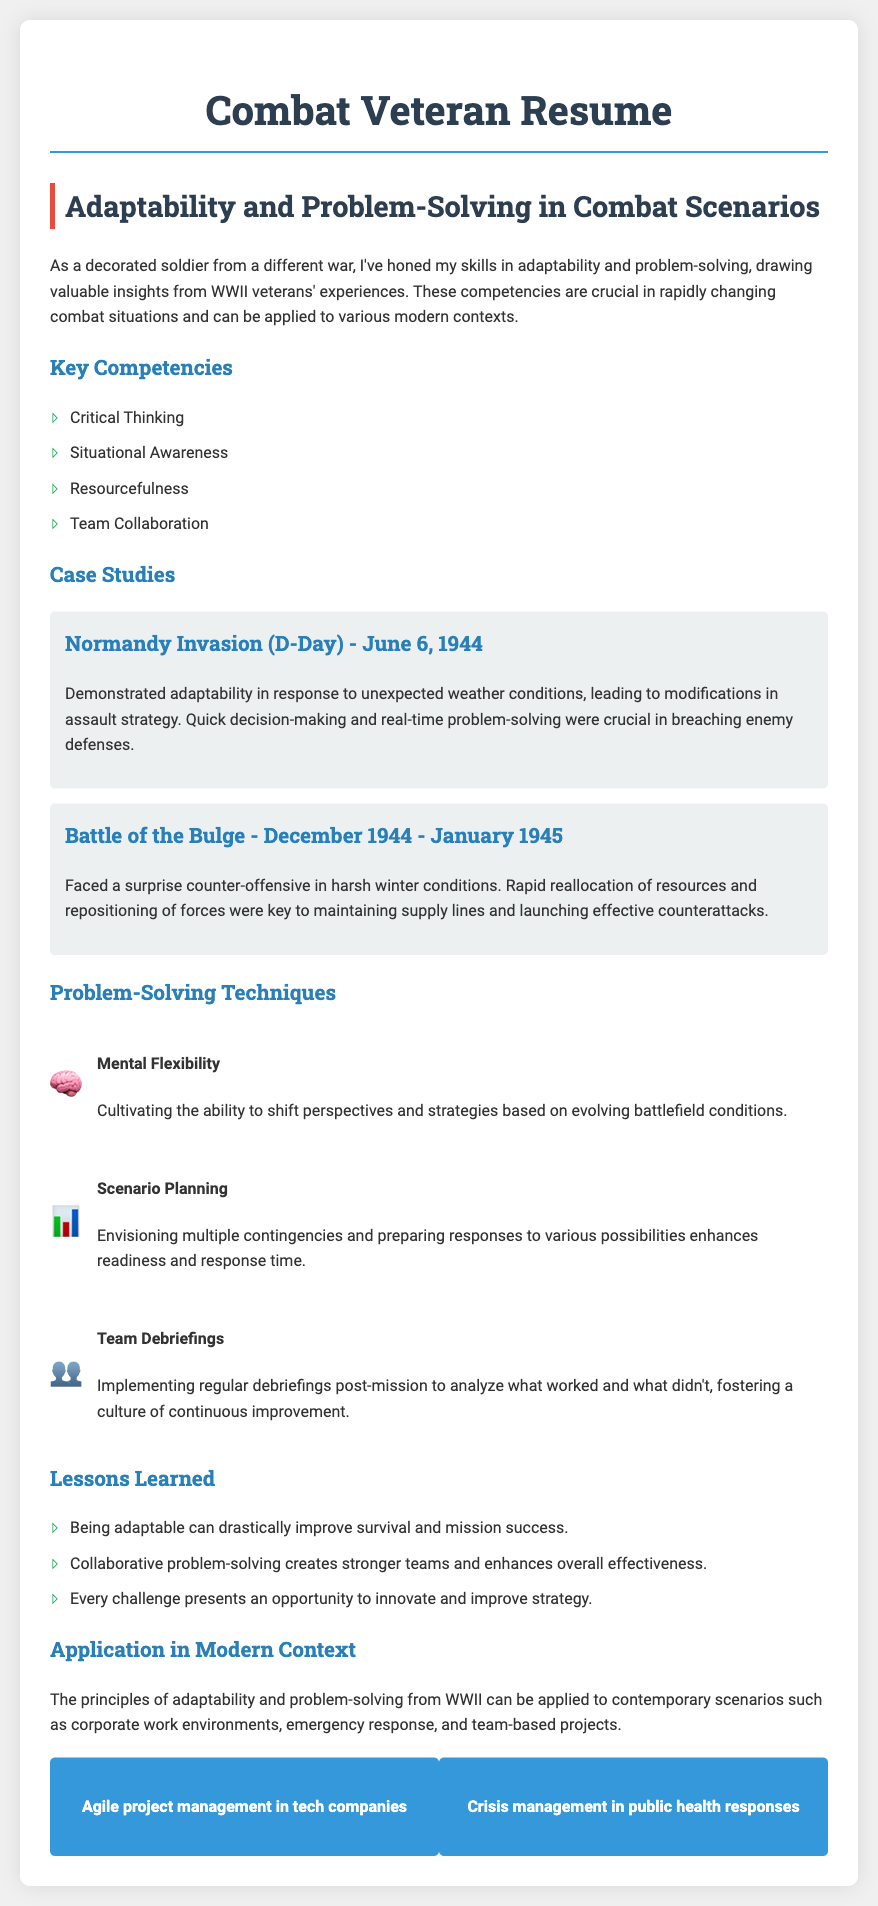what is the title of this document? The title of the document is presented prominently at the top in the header section, indicating the purpose of the document.
Answer: Combat Veteran Resume what date did the Normandy Invasion occur? The document specifies the date of the Normandy Invasion in the case study section for that event.
Answer: June 6, 1944 which problem-solving technique involves shifting perspectives? The document lists various problem-solving techniques, one of which specifically mentions the ability to shift perspectives.
Answer: Mental Flexibility what was a key aspect of the Battle of the Bulge? The case study provides insights into the challenges faced during this battle, pointing out a crucial element of the strategy employed.
Answer: Resource reallocation name one application of WWII principles in modern contexts? The document discusses the application of WWII principles to various contemporary scenarios, one of which is specifically mentioned.
Answer: Agile project management in tech companies how many key competencies are listed in the document? The section listing key competencies outlines distinct qualities, allowing for an easy count of the items presented.
Answer: Four what does scenario planning enhance? The problem-solving technique describes a specific benefit of envisioning multiple contingencies and suggests what improves as a result.
Answer: Readiness what is the main lesson learned mentioned in the document? The lessons learned section summarizes important takeaways from the experiences shared, highlighting one main lesson regarding adaptability.
Answer: Adaptability improves survival and mission success 